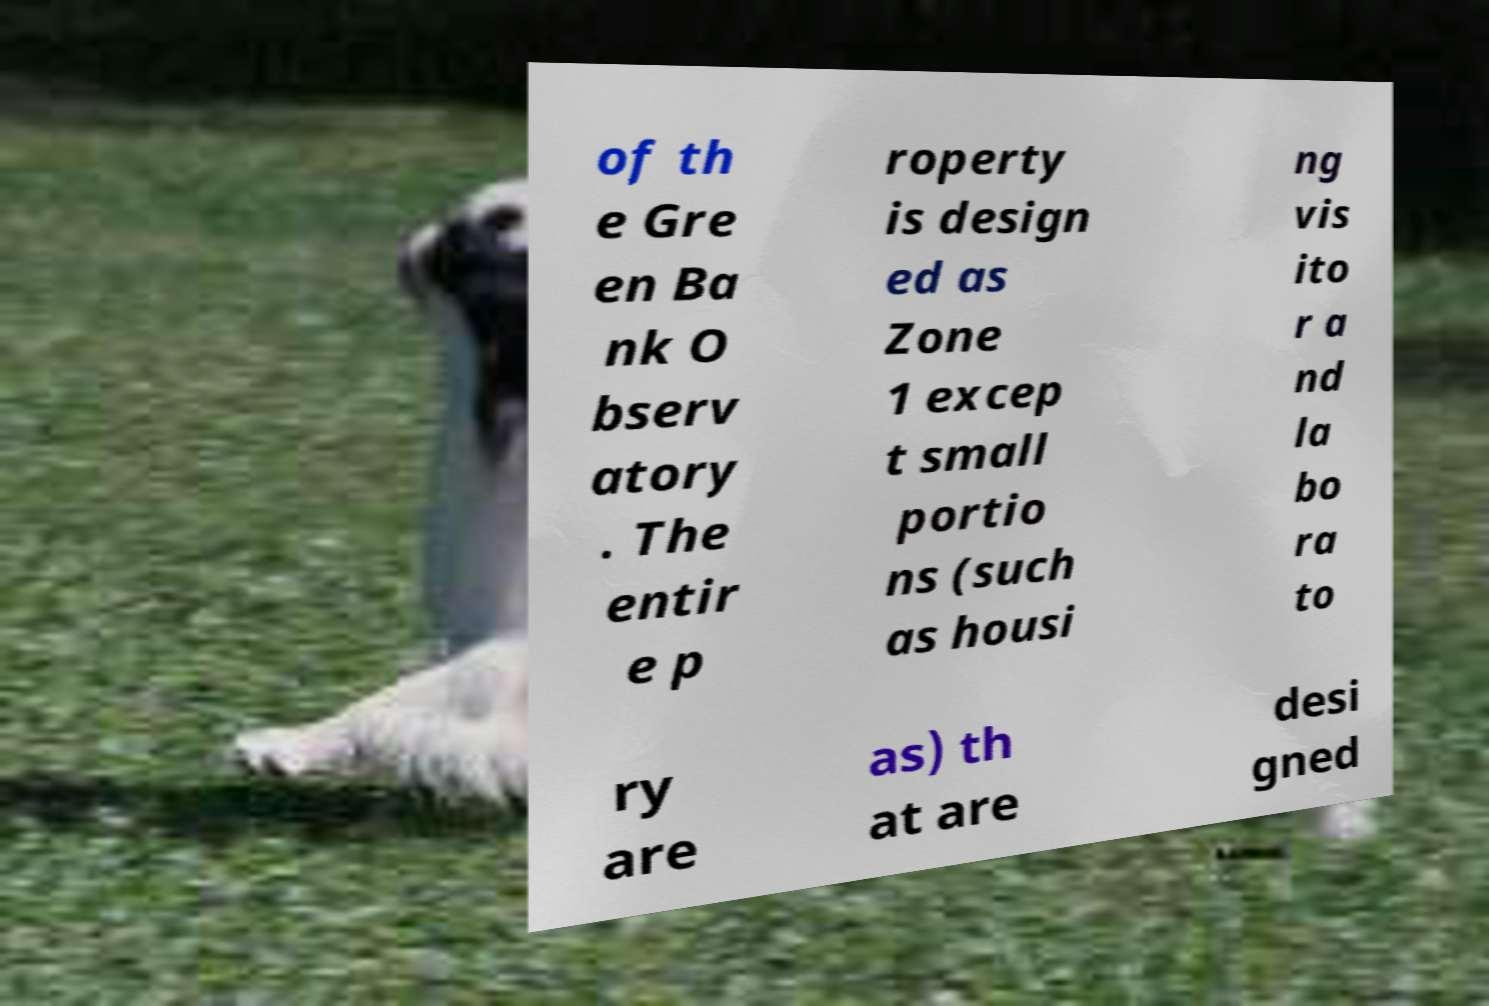Can you read and provide the text displayed in the image?This photo seems to have some interesting text. Can you extract and type it out for me? of th e Gre en Ba nk O bserv atory . The entir e p roperty is design ed as Zone 1 excep t small portio ns (such as housi ng vis ito r a nd la bo ra to ry are as) th at are desi gned 